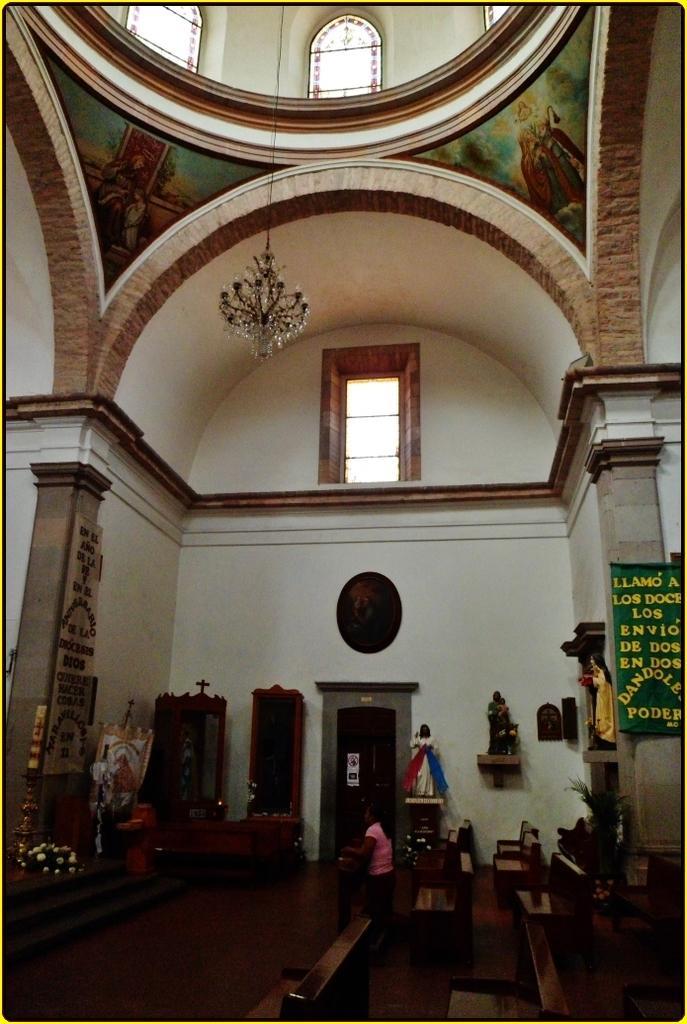Can you describe this image briefly? On the bottom we can see woman who is wearing pink color t-shirt, trouser and she is standing near to the benches. Here we can see a door which is near to the drawers. On the top we can see a chandelier. Here we can see windows. On the right there was a banner. Here we can see a statue which is near to the banner. 